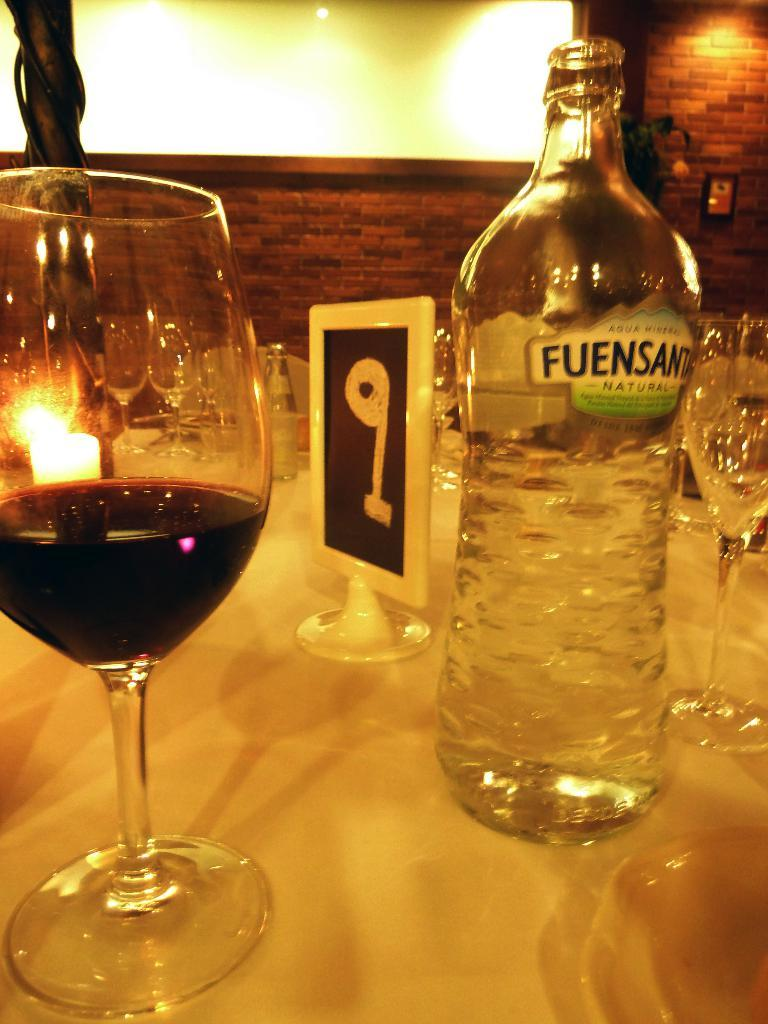What is located in the center of the image? There is a table in the center of the image. What is on the table? There is a wine glass and water bottles on the table. What can be seen in the background of the image? There is a board, a brick wall, and a light in the background of the image. Where is the writer sitting in the image? There is no writer present in the image. What type of sack is visible in the image? There is no sack present in the image. 